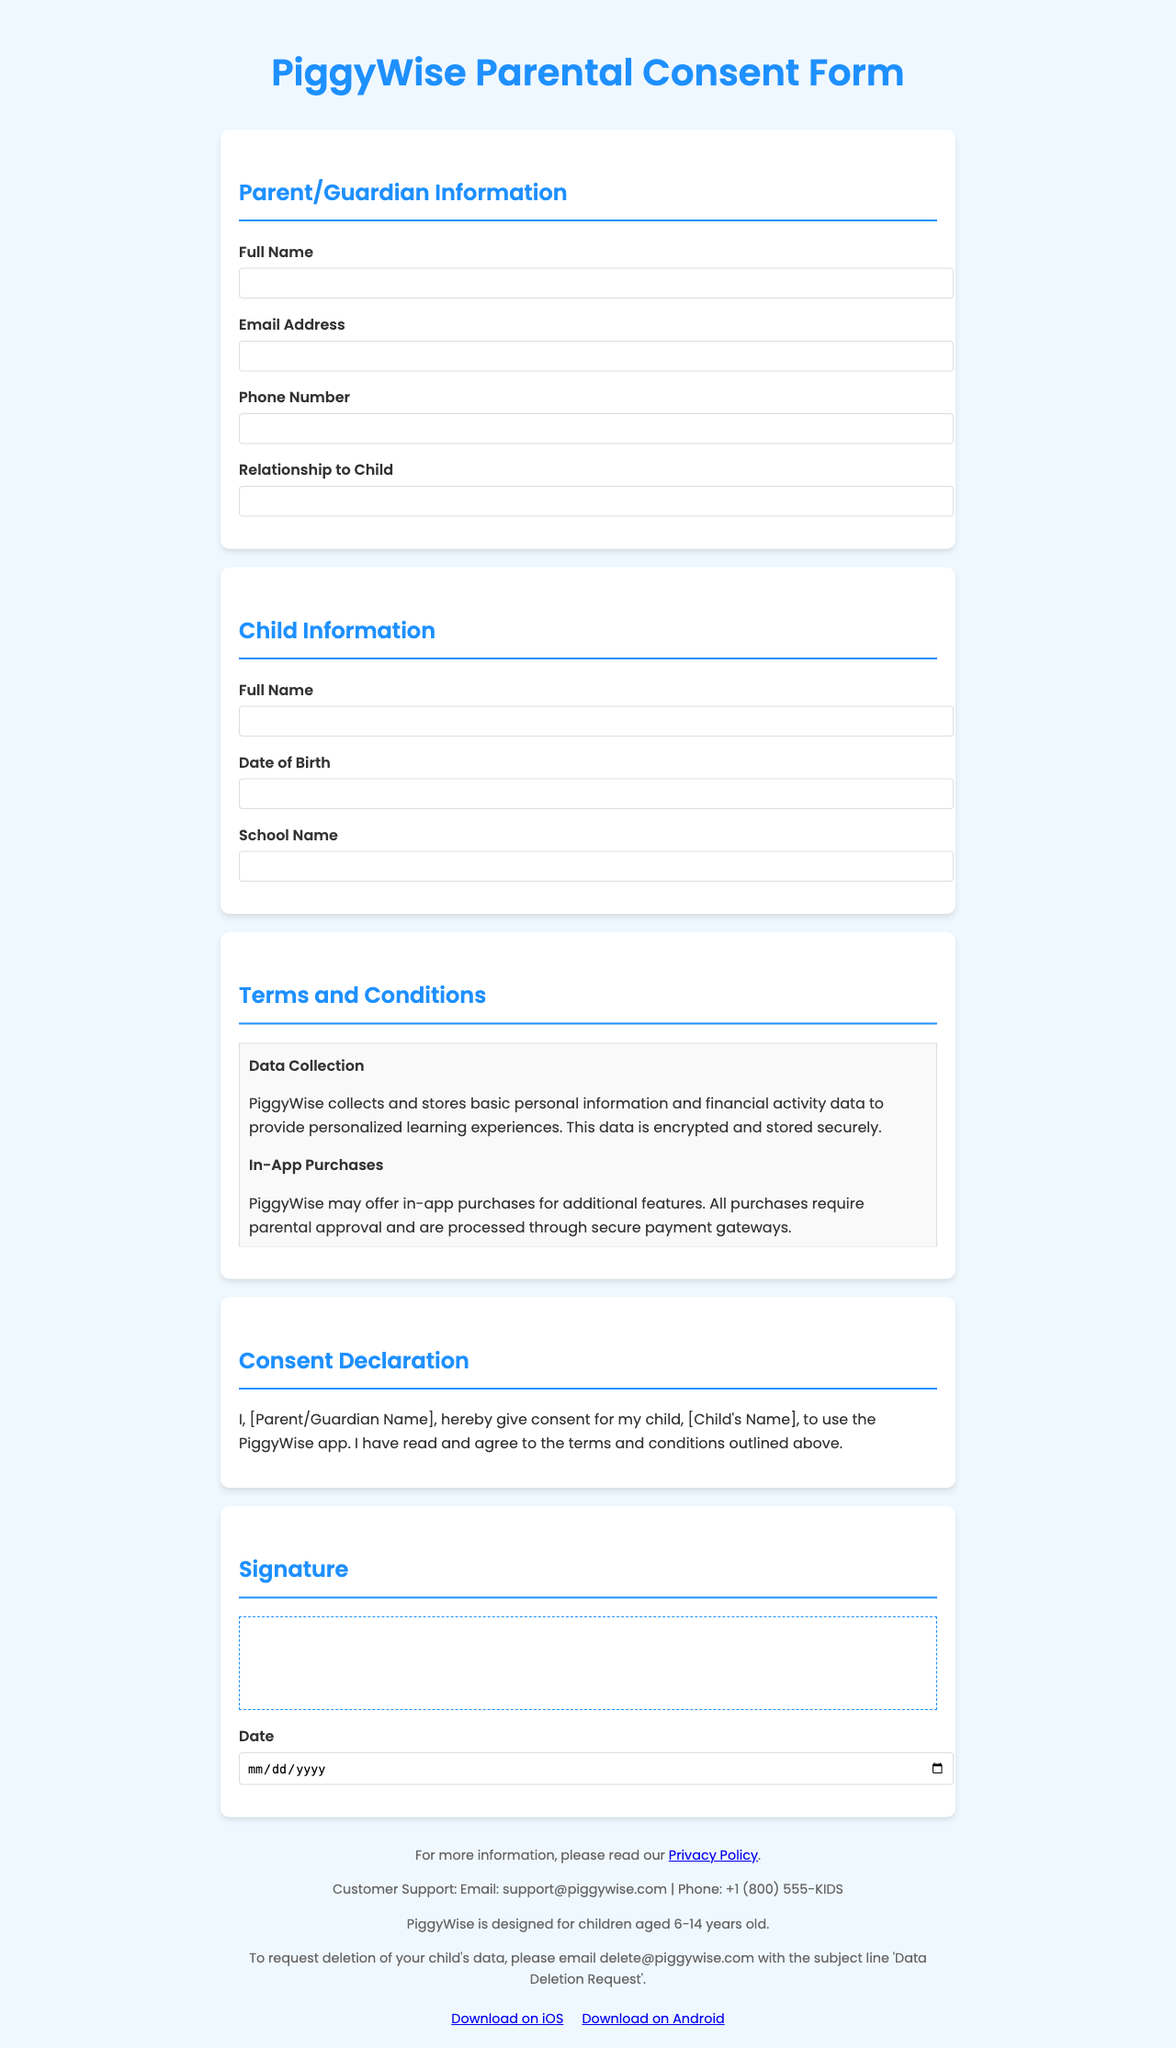what is the name of the app? The name of the app is stated prominently at the top of the document.
Answer: PiggyWise who is the parent company of the app? The company that oversees the app is mentioned near the top of the document.
Answer: FinKids Inc what is the age restriction for using the app? The document specifies the age range intended for the app's users.
Answer: 6-14 years old how can a parent request data deletion? The instructions for requesting data deletion are clearly stated towards the end of the document.
Answer: Email delete@piggywise.com what do we need to approve for in-app purchases? The document mentions the requirement for approval regarding in-app purchases.
Answer: Parental approval what should a parent do to monitor their child's app usage? The document advises parents on what is encouraged for overseeing their child's use of the app.
Answer: Monitor their child's app usage how are third-party services handled in the app? The document includes a clause about the integration of third-party services, along with mention of their own terms and policies.
Answer: They have their own terms and privacy policies what is the purpose of data collection as mentioned in the form? The document clarifies the intended use of collected data for the app’s functionality.
Answer: To provide personalized learning experiences 